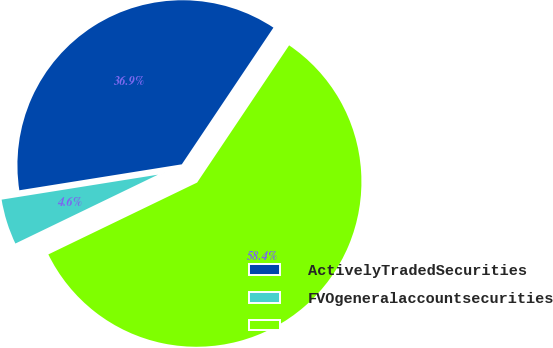Convert chart. <chart><loc_0><loc_0><loc_500><loc_500><pie_chart><fcel>ActivelyTradedSecurities<fcel>FVOgeneralaccountsecurities<fcel>Unnamed: 2<nl><fcel>36.92%<fcel>4.64%<fcel>58.44%<nl></chart> 